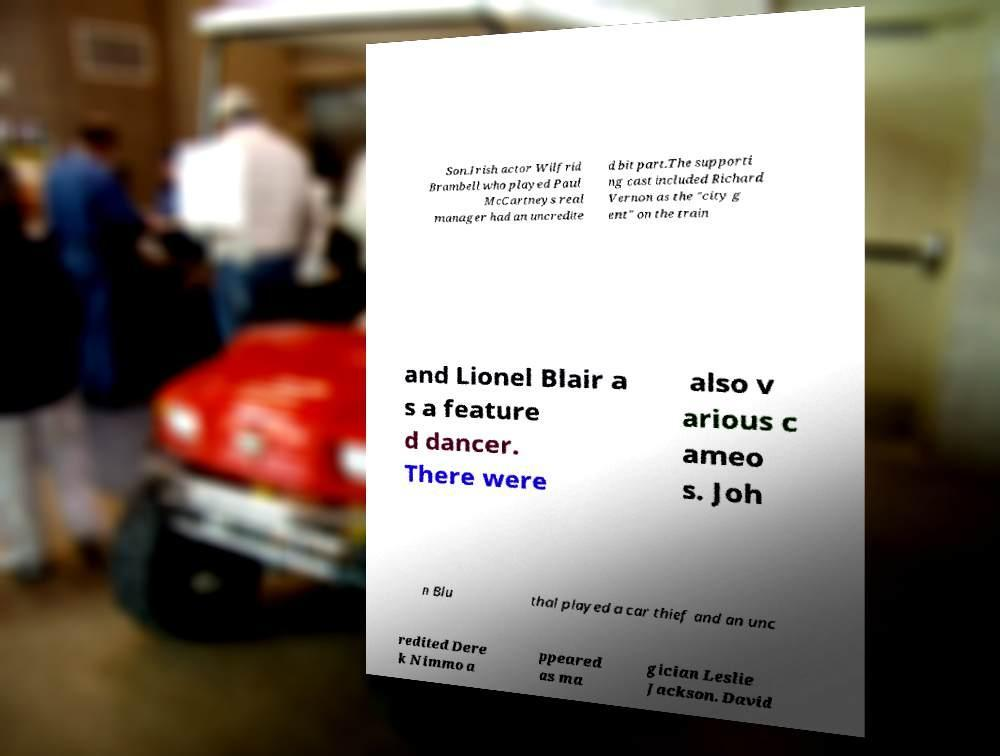Could you extract and type out the text from this image? Son.Irish actor Wilfrid Brambell who played Paul McCartneys real manager had an uncredite d bit part.The supporti ng cast included Richard Vernon as the "city g ent" on the train and Lionel Blair a s a feature d dancer. There were also v arious c ameo s. Joh n Blu thal played a car thief and an unc redited Dere k Nimmo a ppeared as ma gician Leslie Jackson. David 